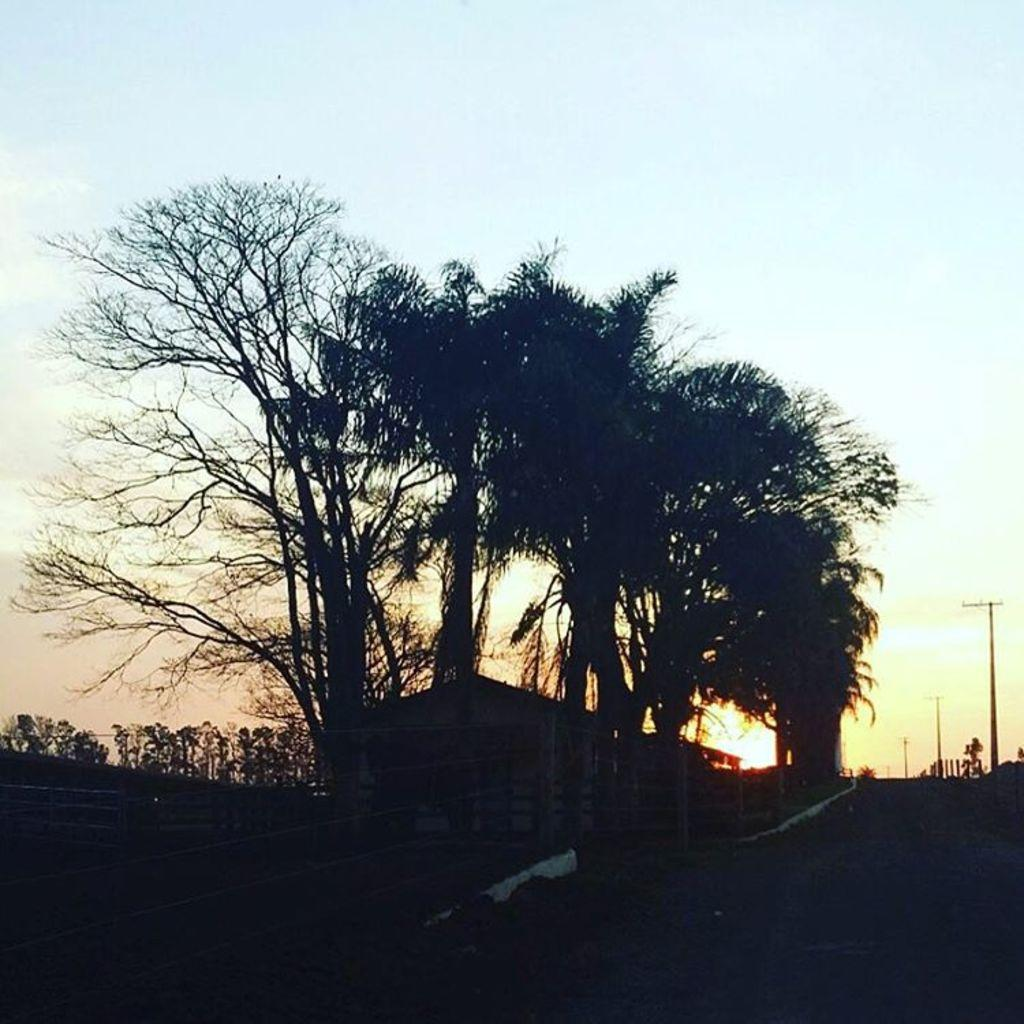What type of natural elements can be seen in the image? There are many trees in the image. What type of man-made structures are present in the image? There are buildings in the image. What type of architectural feature can be seen in the image? Railings are present in the image. What objects are on the right side of the image? There are poles on the right side of the image. What is visible in the background of the image? The sky is visible in the background of the image. What verse is being recited by the representative in the image? There is no representative or verse present in the image. What type of emotion is being expressed by the person in the image? There is no person present in the image, so it is not possible to determine their emotions. 